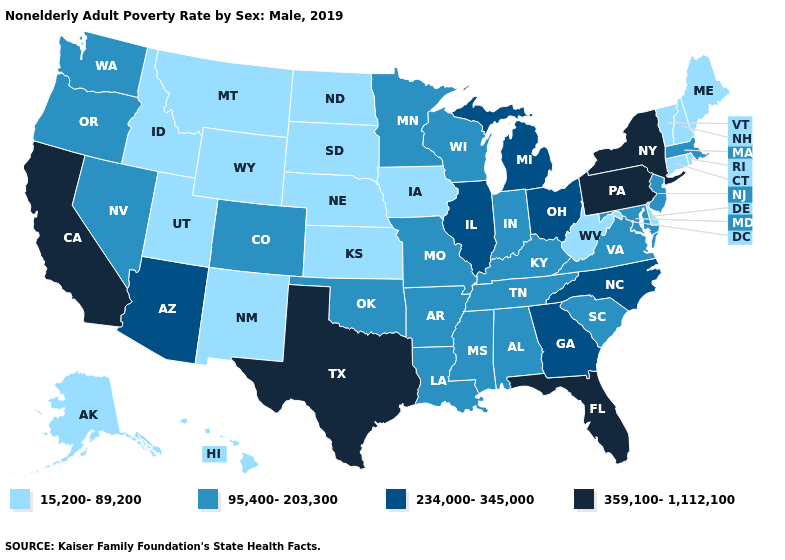Among the states that border Georgia , does North Carolina have the lowest value?
Answer briefly. No. Among the states that border Illinois , does Missouri have the lowest value?
Write a very short answer. No. Among the states that border Maryland , which have the lowest value?
Short answer required. Delaware, West Virginia. Name the states that have a value in the range 234,000-345,000?
Short answer required. Arizona, Georgia, Illinois, Michigan, North Carolina, Ohio. Does Arkansas have the highest value in the South?
Keep it brief. No. What is the highest value in the USA?
Short answer required. 359,100-1,112,100. Name the states that have a value in the range 359,100-1,112,100?
Quick response, please. California, Florida, New York, Pennsylvania, Texas. Among the states that border Kentucky , does Ohio have the highest value?
Answer briefly. Yes. What is the value of New Jersey?
Write a very short answer. 95,400-203,300. Which states have the lowest value in the USA?
Be succinct. Alaska, Connecticut, Delaware, Hawaii, Idaho, Iowa, Kansas, Maine, Montana, Nebraska, New Hampshire, New Mexico, North Dakota, Rhode Island, South Dakota, Utah, Vermont, West Virginia, Wyoming. Name the states that have a value in the range 234,000-345,000?
Give a very brief answer. Arizona, Georgia, Illinois, Michigan, North Carolina, Ohio. Name the states that have a value in the range 95,400-203,300?
Keep it brief. Alabama, Arkansas, Colorado, Indiana, Kentucky, Louisiana, Maryland, Massachusetts, Minnesota, Mississippi, Missouri, Nevada, New Jersey, Oklahoma, Oregon, South Carolina, Tennessee, Virginia, Washington, Wisconsin. Name the states that have a value in the range 359,100-1,112,100?
Keep it brief. California, Florida, New York, Pennsylvania, Texas. Which states have the lowest value in the MidWest?
Be succinct. Iowa, Kansas, Nebraska, North Dakota, South Dakota. What is the highest value in states that border Nevada?
Write a very short answer. 359,100-1,112,100. 